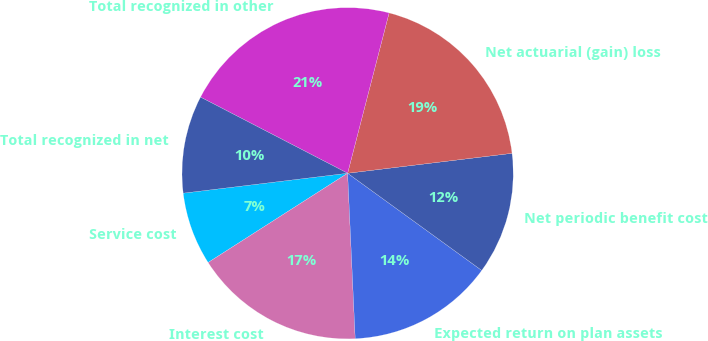<chart> <loc_0><loc_0><loc_500><loc_500><pie_chart><fcel>Service cost<fcel>Interest cost<fcel>Expected return on plan assets<fcel>Net periodic benefit cost<fcel>Net actuarial (gain) loss<fcel>Total recognized in other<fcel>Total recognized in net<nl><fcel>7.14%<fcel>16.67%<fcel>14.29%<fcel>11.9%<fcel>19.05%<fcel>21.43%<fcel>9.52%<nl></chart> 